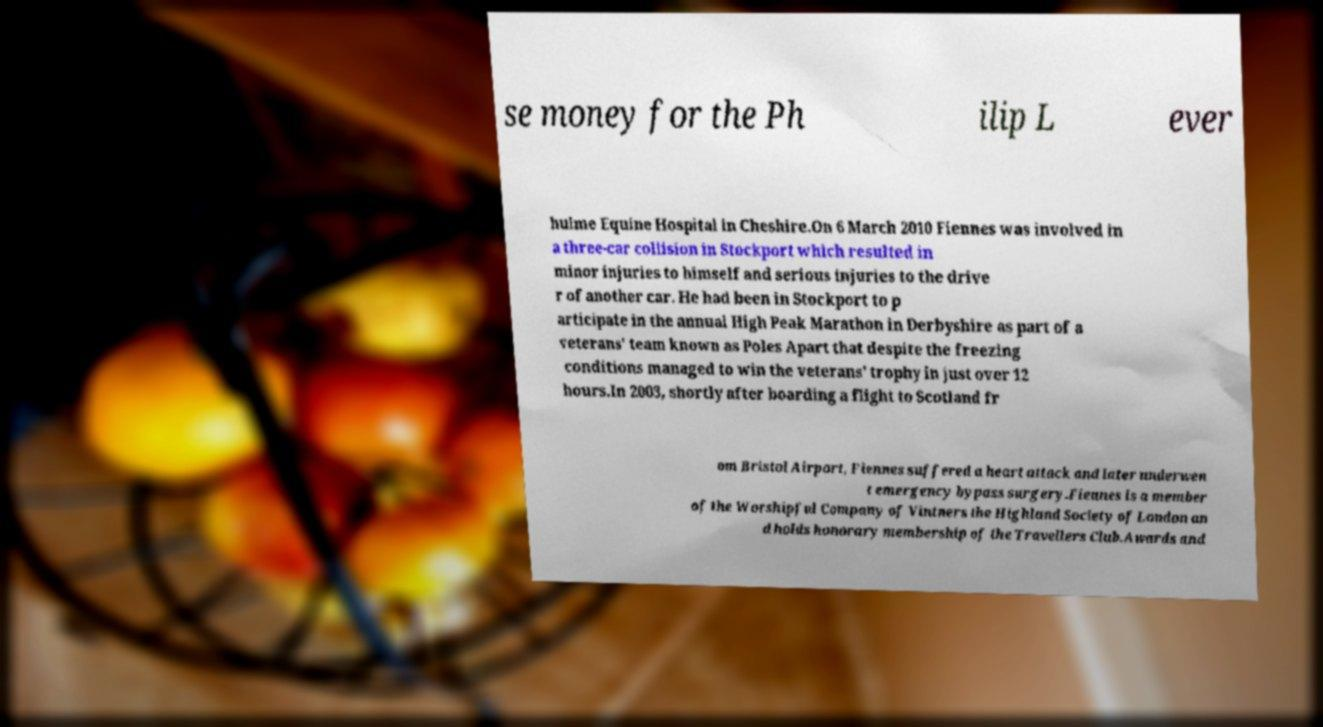I need the written content from this picture converted into text. Can you do that? se money for the Ph ilip L ever hulme Equine Hospital in Cheshire.On 6 March 2010 Fiennes was involved in a three-car collision in Stockport which resulted in minor injuries to himself and serious injuries to the drive r of another car. He had been in Stockport to p articipate in the annual High Peak Marathon in Derbyshire as part of a veterans' team known as Poles Apart that despite the freezing conditions managed to win the veterans' trophy in just over 12 hours.In 2003, shortly after boarding a flight to Scotland fr om Bristol Airport, Fiennes suffered a heart attack and later underwen t emergency bypass surgery.Fiennes is a member of the Worshipful Company of Vintners the Highland Society of London an d holds honorary membership of the Travellers Club.Awards and 